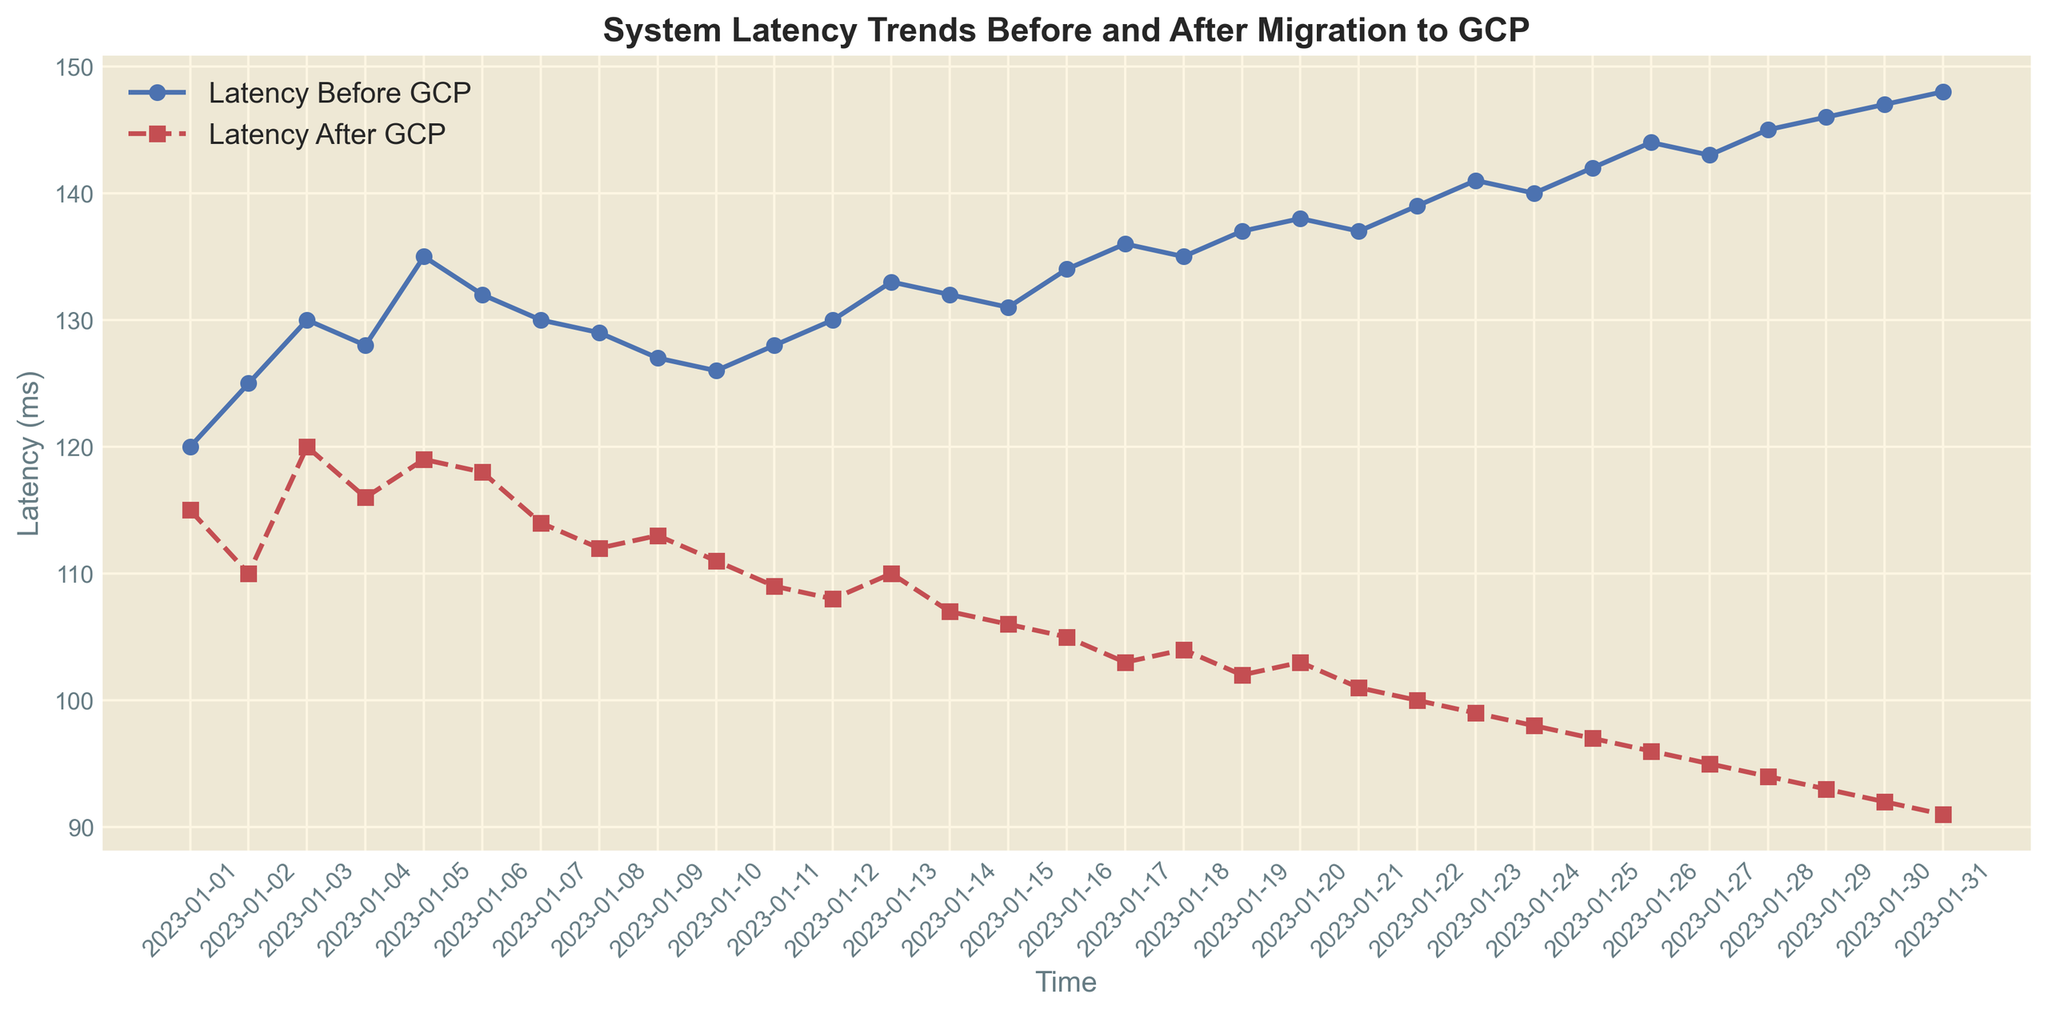What's the trend of latency before and after migrating to GCP over time? To observe the trend, follow the plotted points of 'Latency Before GCP' and 'Latency After GCP' lines. The latency before GCP is consistently higher than after GCP, and both show a general increasing trend over time, but the increase is more gradual after the migration.
Answer: Increasing On which date does the largest difference in latency between before and after GCP occur? The largest difference occurs when the gap between 'Latency Before GCP' and 'Latency After GCP' is maximal. The highest difference is on 2023-01-31, where the latency before GCP is 148 ms and after GCP is 91 ms.
Answer: 2023-01-31 What is the average latency before and after GCP for the first 10 days? To find this, sum the latency values for the first 10 days and divide each sum by 10. Before GCP: (120 + 125 + 130 + 128 + 135 + 132 + 130 + 129 + 127 + 126)/10 = 128.2 ms. After GCP: (115 + 110 + 120 + 116 + 119 + 118 + 114 + 112 + 113 + 111)/10 = 114.8 ms.
Answer: 128.2 ms, 114.8 ms How does the variability (fluctuation) in latency before GCP compare to after GCP? Examine how the peaks and troughs differ between 'Latency Before GCP' and 'Latency After GCP'. Latency before GCP has more variability and larger fluctuations than after GCP, which shows more stable and consistent values.
Answer: More variability before GCP Is there any date where the latency after GCP is higher than the latency before GCP? Check each date to see if the data point for 'Latency After GCP' is above the corresponding 'Latency Before GCP' point. There is no date where the latency after GCP is higher than the latency before GCP.
Answer: No Which latency, before or after GCP, had a faster rate of increase over time? Compare the slopes of the lines representing 'Latency Before GCP' and 'Latency After GCP'. The 'Latency Before GCP' line has a steeper slope, indicating a faster rate of increase over time as compared to 'Latency After GCP'.
Answer: Before GCP What is the difference in latency between the start (2023-01-01) and end (2023-01-31) of the dataset for both before and after GCP? Subtract the latency on 2023-01-01 from the latency on 2023-01-31 for both. Before GCP: 148 - 120 = 28 ms. After GCP: 91 - 115 = -24 ms (indicates a decrease).
Answer: 28 ms, -24 ms Which color represents the latency after the migration to GCP in the plot? Refer to the legend in the plot to identify the color representing 'Latency After GCP'. The color used for 'Latency After GCP' is red.
Answer: Red What is the median latency after GCP for the given dates? List out and sort the 'Latency After GCP' values: 91, 92, 93, 94, 95, 96, 97, 98, 99, 100, 101, 102, 103, 104, 105, 106, 107, 108, 109, 110, 111, 112, 113, 114, 116, 118, 119, 120. For even number of items, take average of two middle values (105 and 106): (105 + 106)/2 = 105.5 ms.
Answer: 105.5 ms 